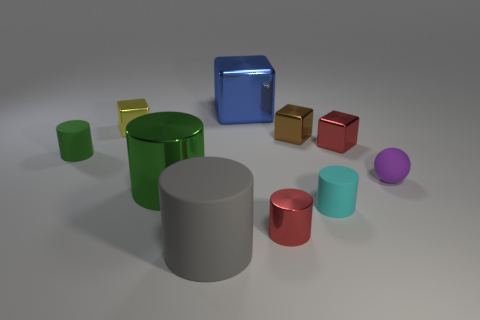Subtract all small cyan cylinders. How many cylinders are left? 4 Subtract 2 cylinders. How many cylinders are left? 3 Subtract all gray cylinders. How many cylinders are left? 4 Subtract all yellow cylinders. Subtract all red spheres. How many cylinders are left? 5 Subtract all spheres. How many objects are left? 9 Add 4 small blue objects. How many small blue objects exist? 4 Subtract 0 yellow balls. How many objects are left? 10 Subtract all large gray balls. Subtract all green cylinders. How many objects are left? 8 Add 5 large blocks. How many large blocks are left? 6 